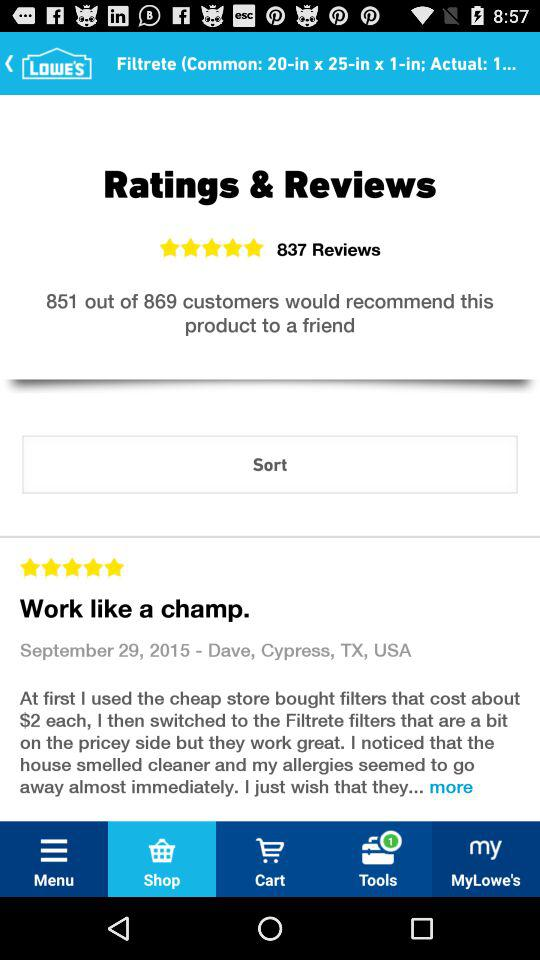What is the rating of the products? The rating of the product is 5 stars. 